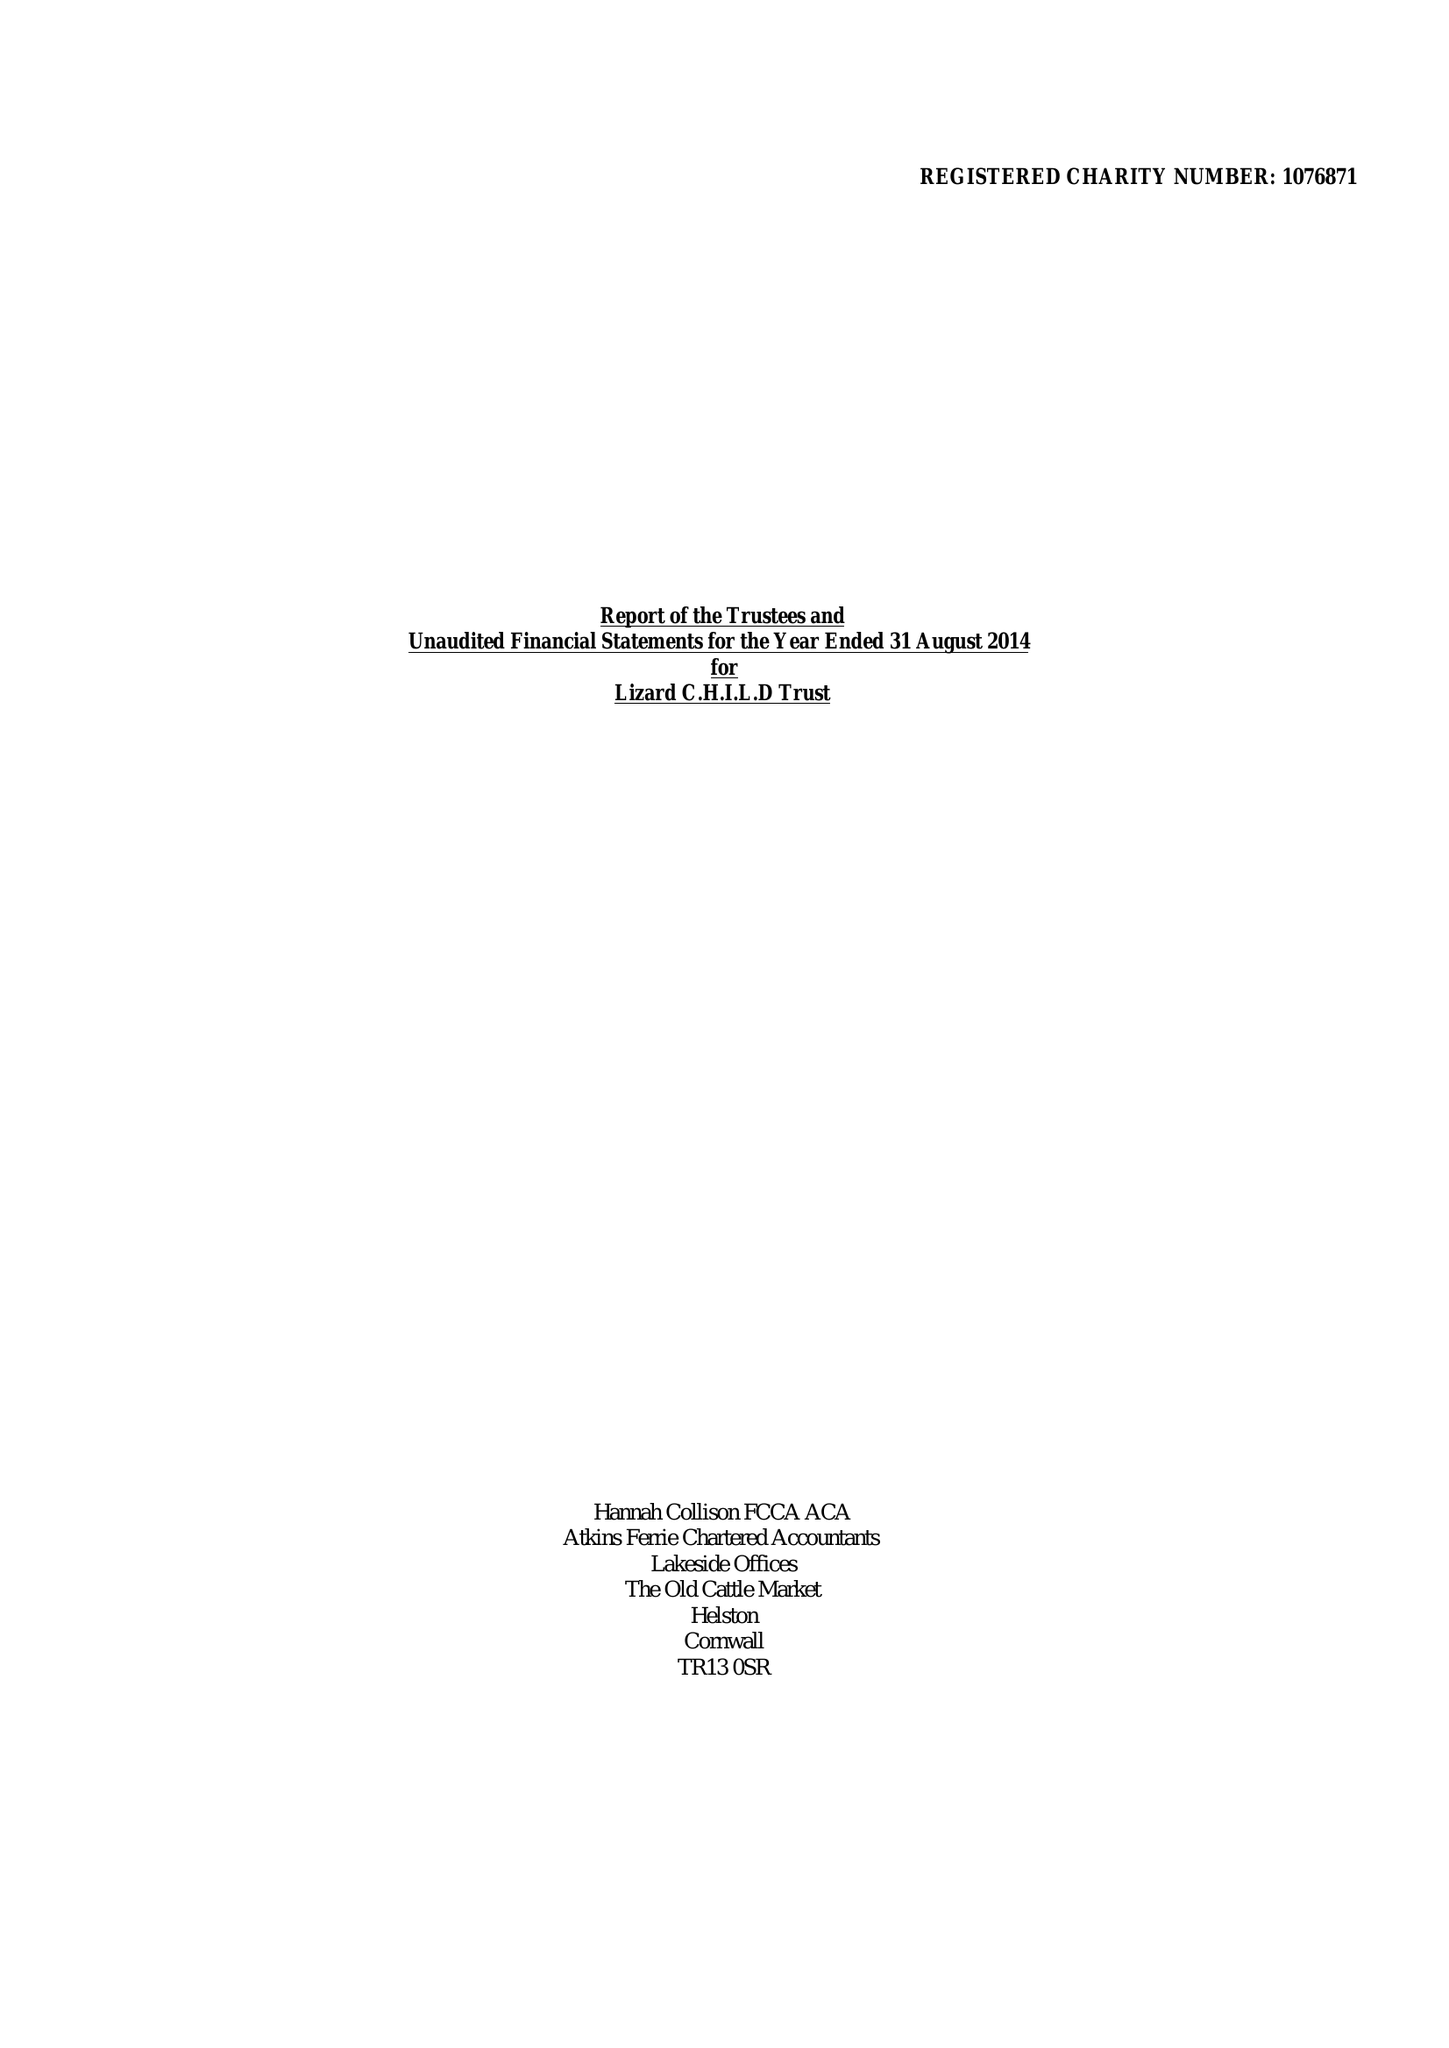What is the value for the charity_name?
Answer the question using a single word or phrase. Lizard C.H.I.L.D. Trust 